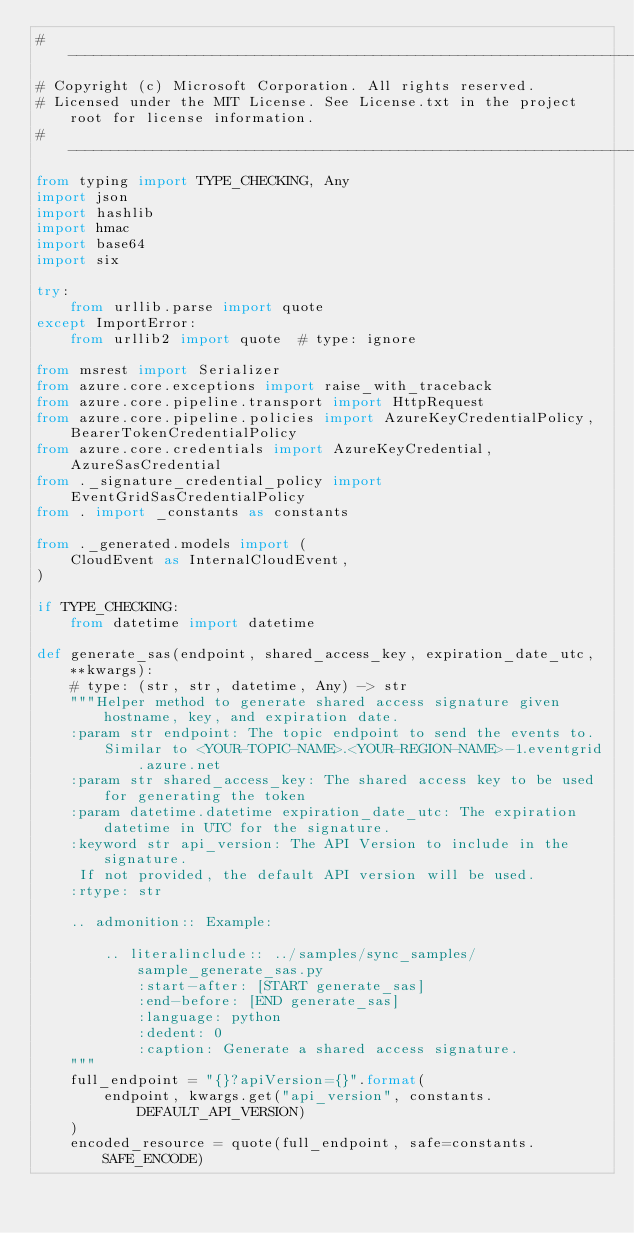<code> <loc_0><loc_0><loc_500><loc_500><_Python_># --------------------------------------------------------------------------------------------
# Copyright (c) Microsoft Corporation. All rights reserved.
# Licensed under the MIT License. See License.txt in the project root for license information.
# --------------------------------------------------------------------------------------------
from typing import TYPE_CHECKING, Any
import json
import hashlib
import hmac
import base64
import six

try:
    from urllib.parse import quote
except ImportError:
    from urllib2 import quote  # type: ignore

from msrest import Serializer
from azure.core.exceptions import raise_with_traceback
from azure.core.pipeline.transport import HttpRequest
from azure.core.pipeline.policies import AzureKeyCredentialPolicy, BearerTokenCredentialPolicy
from azure.core.credentials import AzureKeyCredential, AzureSasCredential
from ._signature_credential_policy import EventGridSasCredentialPolicy
from . import _constants as constants

from ._generated.models import (
    CloudEvent as InternalCloudEvent,
)

if TYPE_CHECKING:
    from datetime import datetime

def generate_sas(endpoint, shared_access_key, expiration_date_utc, **kwargs):
    # type: (str, str, datetime, Any) -> str
    """Helper method to generate shared access signature given hostname, key, and expiration date.
    :param str endpoint: The topic endpoint to send the events to.
        Similar to <YOUR-TOPIC-NAME>.<YOUR-REGION-NAME>-1.eventgrid.azure.net
    :param str shared_access_key: The shared access key to be used for generating the token
    :param datetime.datetime expiration_date_utc: The expiration datetime in UTC for the signature.
    :keyword str api_version: The API Version to include in the signature.
     If not provided, the default API version will be used.
    :rtype: str

    .. admonition:: Example:

        .. literalinclude:: ../samples/sync_samples/sample_generate_sas.py
            :start-after: [START generate_sas]
            :end-before: [END generate_sas]
            :language: python
            :dedent: 0
            :caption: Generate a shared access signature.
    """
    full_endpoint = "{}?apiVersion={}".format(
        endpoint, kwargs.get("api_version", constants.DEFAULT_API_VERSION)
    )
    encoded_resource = quote(full_endpoint, safe=constants.SAFE_ENCODE)</code> 